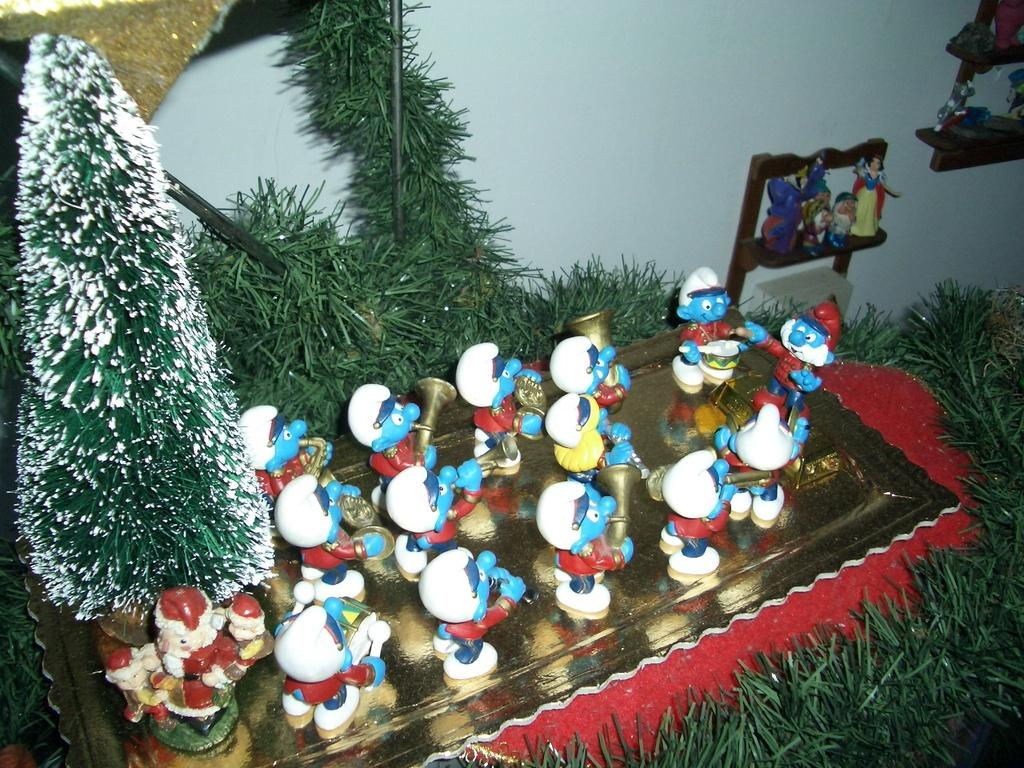What type of vegetation can be seen in the image? There is grass in the image. What objects are on a platform in the image? There are toys on a platform in the image. What type of natural structures are visible in the image? There are trees in the image. What architectural feature can be seen in the background of the image? There is a wall visible in the background of the image. How many faces can be seen on the trees in the image? There are no faces visible on the trees in the image. What type of sugar is being used to decorate the grass in the image? There is no sugar present in the image; it features grass and trees. 